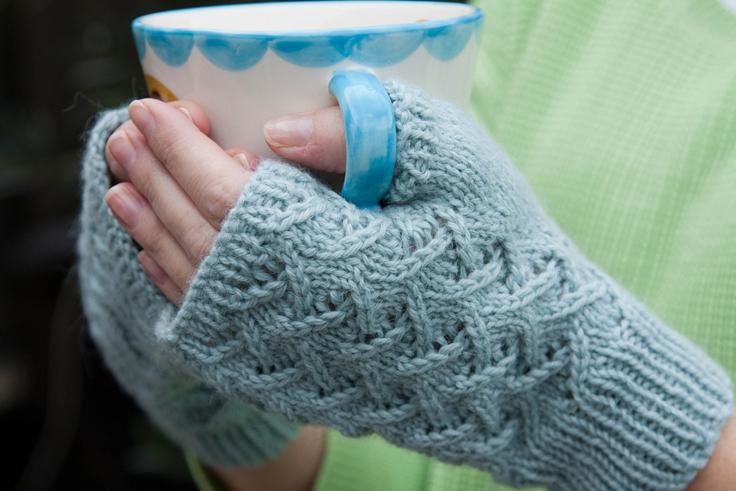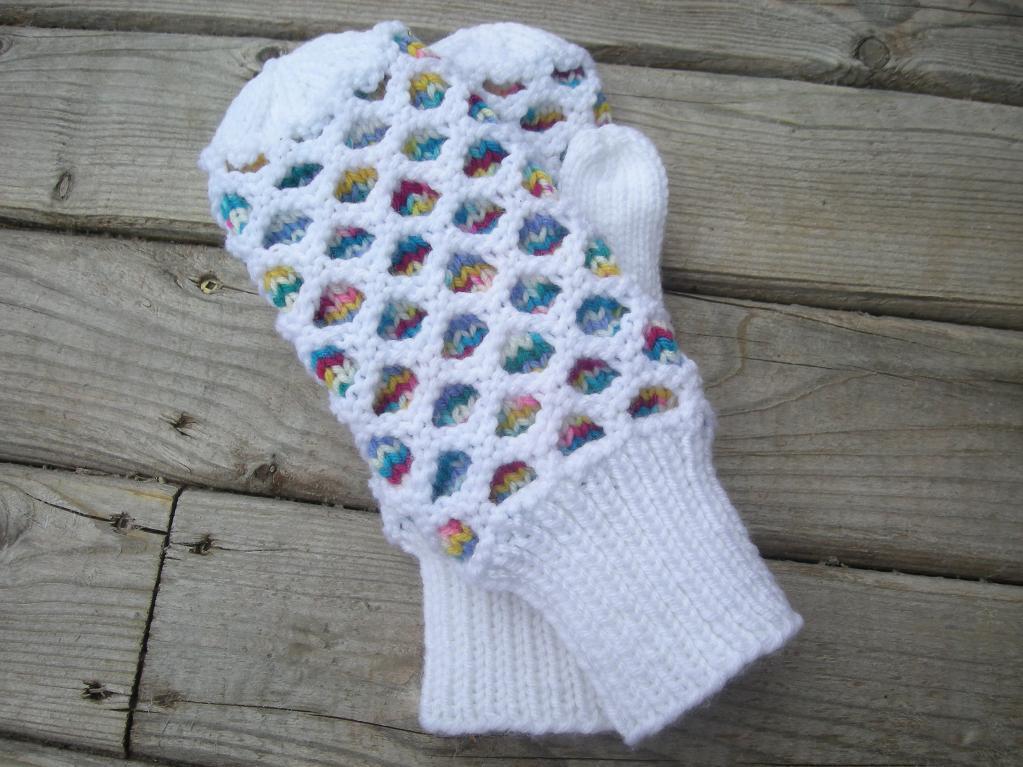The first image is the image on the left, the second image is the image on the right. Assess this claim about the two images: "The mittens in the left image are on a pair of human hands.". Correct or not? Answer yes or no. Yes. The first image is the image on the left, the second image is the image on the right. Analyze the images presented: Is the assertion "One pair of mittens features at least two or more colors in a patterned design." valid? Answer yes or no. Yes. 